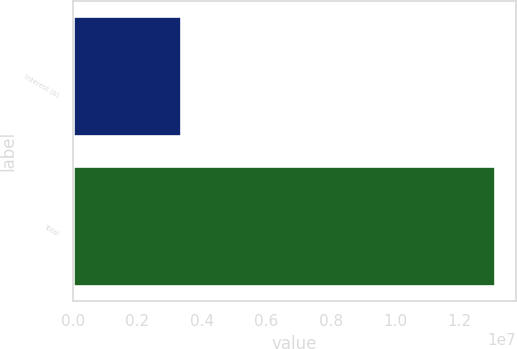Convert chart. <chart><loc_0><loc_0><loc_500><loc_500><bar_chart><fcel>Interest (b)<fcel>Total<nl><fcel>3.35119e+06<fcel>1.30864e+07<nl></chart> 